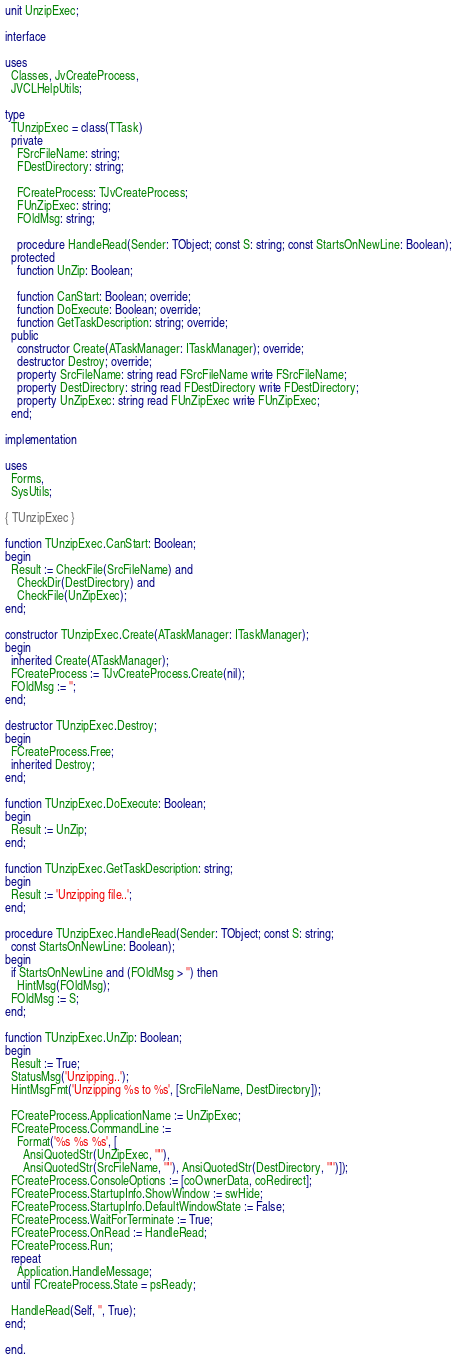<code> <loc_0><loc_0><loc_500><loc_500><_Pascal_>unit UnzipExec;

interface

uses
  Classes, JvCreateProcess,
  JVCLHelpUtils;

type
  TUnzipExec = class(TTask)
  private
    FSrcFileName: string;
    FDestDirectory: string;

    FCreateProcess: TJvCreateProcess;
    FUnZipExec: string;
    FOldMsg: string;

    procedure HandleRead(Sender: TObject; const S: string; const StartsOnNewLine: Boolean);
  protected
    function UnZip: Boolean;

    function CanStart: Boolean; override;
    function DoExecute: Boolean; override;
    function GetTaskDescription: string; override;
  public
    constructor Create(ATaskManager: ITaskManager); override;
    destructor Destroy; override;
    property SrcFileName: string read FSrcFileName write FSrcFileName;
    property DestDirectory: string read FDestDirectory write FDestDirectory;
    property UnZipExec: string read FUnZipExec write FUnZipExec;
  end;

implementation

uses
  Forms,
  SysUtils;

{ TUnzipExec }

function TUnzipExec.CanStart: Boolean;
begin
  Result := CheckFile(SrcFileName) and
    CheckDir(DestDirectory) and
    CheckFile(UnZipExec);
end;

constructor TUnzipExec.Create(ATaskManager: ITaskManager);
begin
  inherited Create(ATaskManager);
  FCreateProcess := TJvCreateProcess.Create(nil);
  FOldMsg := '';
end;

destructor TUnzipExec.Destroy;
begin
  FCreateProcess.Free;
  inherited Destroy;
end;

function TUnzipExec.DoExecute: Boolean;
begin
  Result := UnZip;
end;

function TUnzipExec.GetTaskDescription: string;
begin
  Result := 'Unzipping file..';
end;

procedure TUnzipExec.HandleRead(Sender: TObject; const S: string;
  const StartsOnNewLine: Boolean);
begin
  if StartsOnNewLine and (FOldMsg > '') then
    HintMsg(FOldMsg);
  FOldMsg := S;
end;

function TUnzipExec.UnZip: Boolean;
begin
  Result := True;
  StatusMsg('Unzipping..');
  HintMsgFmt('Unzipping %s to %s', [SrcFileName, DestDirectory]);

  FCreateProcess.ApplicationName := UnZipExec;
  FCreateProcess.CommandLine :=
    Format('%s %s %s', [
      AnsiQuotedStr(UnZipExec, '"'),
      AnsiQuotedStr(SrcFileName, '"'), AnsiQuotedStr(DestDirectory, '"')]);
  FCreateProcess.ConsoleOptions := [coOwnerData, coRedirect];
  FCreateProcess.StartupInfo.ShowWindow := swHide;
  FCreateProcess.StartupInfo.DefaultWindowState := False;
  FCreateProcess.WaitForTerminate := True;
  FCreateProcess.OnRead := HandleRead;
  FCreateProcess.Run;
  repeat
    Application.HandleMessage;
  until FCreateProcess.State = psReady;

  HandleRead(Self, '', True);
end;

end.

</code> 